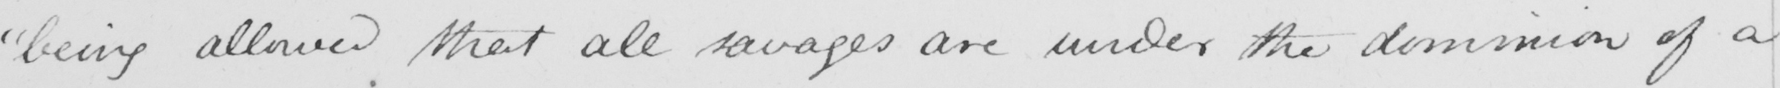What does this handwritten line say? " being allowed that all savages are under the dominion of a 